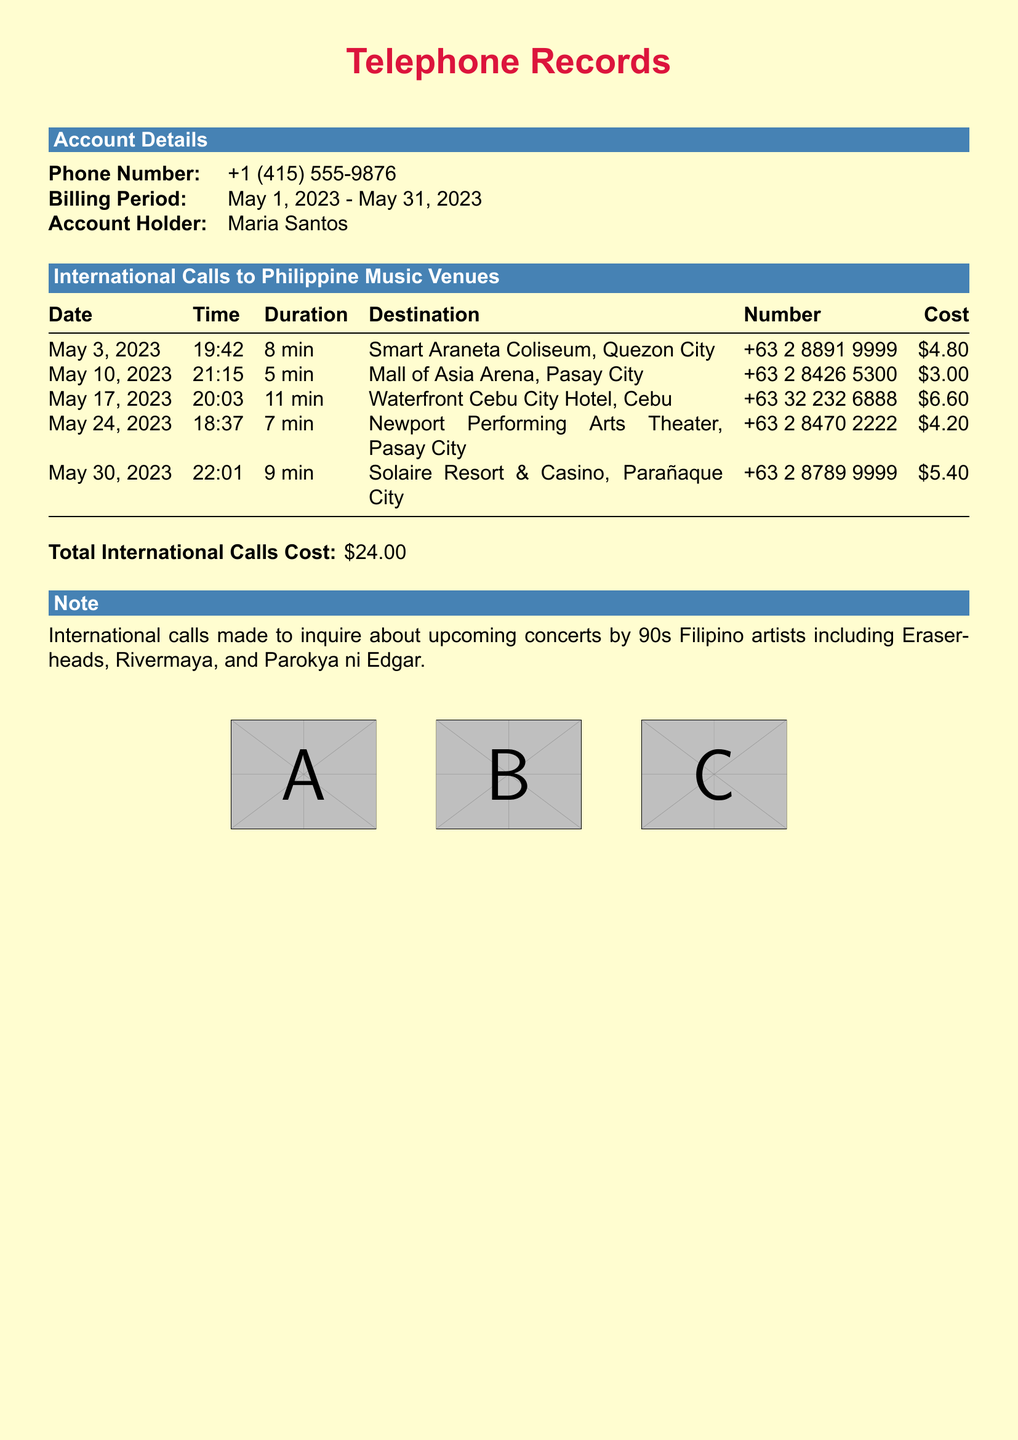What is the phone number of the account holder? The phone number of the account holder is stated at the beginning of the document.
Answer: +1 (415) 555-9876 What was the billing period? The billing period is specified in the account details section.
Answer: May 1, 2023 - May 31, 2023 How many minutes was the longest call? The longest call is determined by comparing the durations listed for each call.
Answer: 11 min What is the total cost of international calls? The total cost is listed at the bottom of the international calls table.
Answer: $24.00 Which venue had the call made on May 10, 2023? The document specifies the venue associated with each call date.
Answer: Mall of Asia Arena, Pasay City How many calls were made to venues in Pasay City? By reviewing the table, you can count the entries for Pasay City.
Answer: 2 What is the destination of the call made on May 17, 2023? The destination is recorded in the table under the date May 17, 2023.
Answer: Waterfront Cebu City Hotel, Cebu What is one of the artists mentioned in the note? The note at the bottom mentions several artists related to the calls made.
Answer: Eraserheads Which call had the highest cost? The costs are listed next to each call, allowing for comparison to find the highest.
Answer: $6.60 